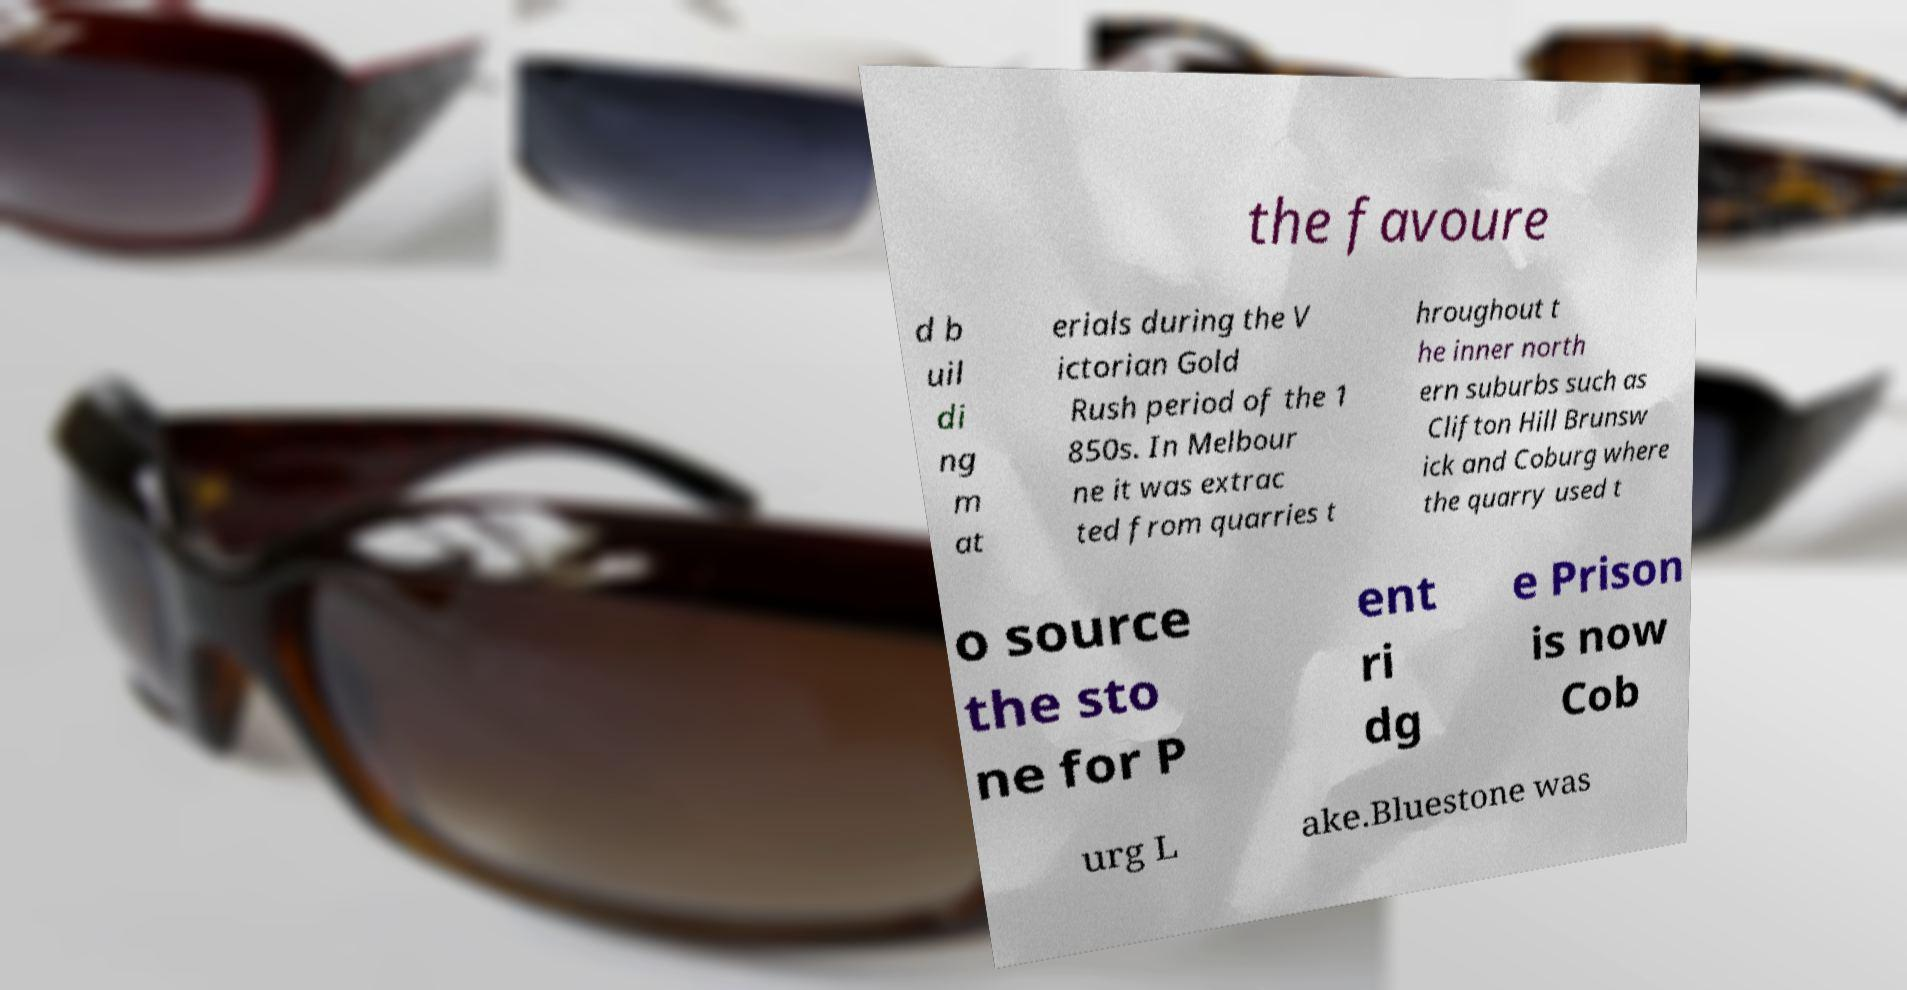Could you assist in decoding the text presented in this image and type it out clearly? the favoure d b uil di ng m at erials during the V ictorian Gold Rush period of the 1 850s. In Melbour ne it was extrac ted from quarries t hroughout t he inner north ern suburbs such as Clifton Hill Brunsw ick and Coburg where the quarry used t o source the sto ne for P ent ri dg e Prison is now Cob urg L ake.Bluestone was 